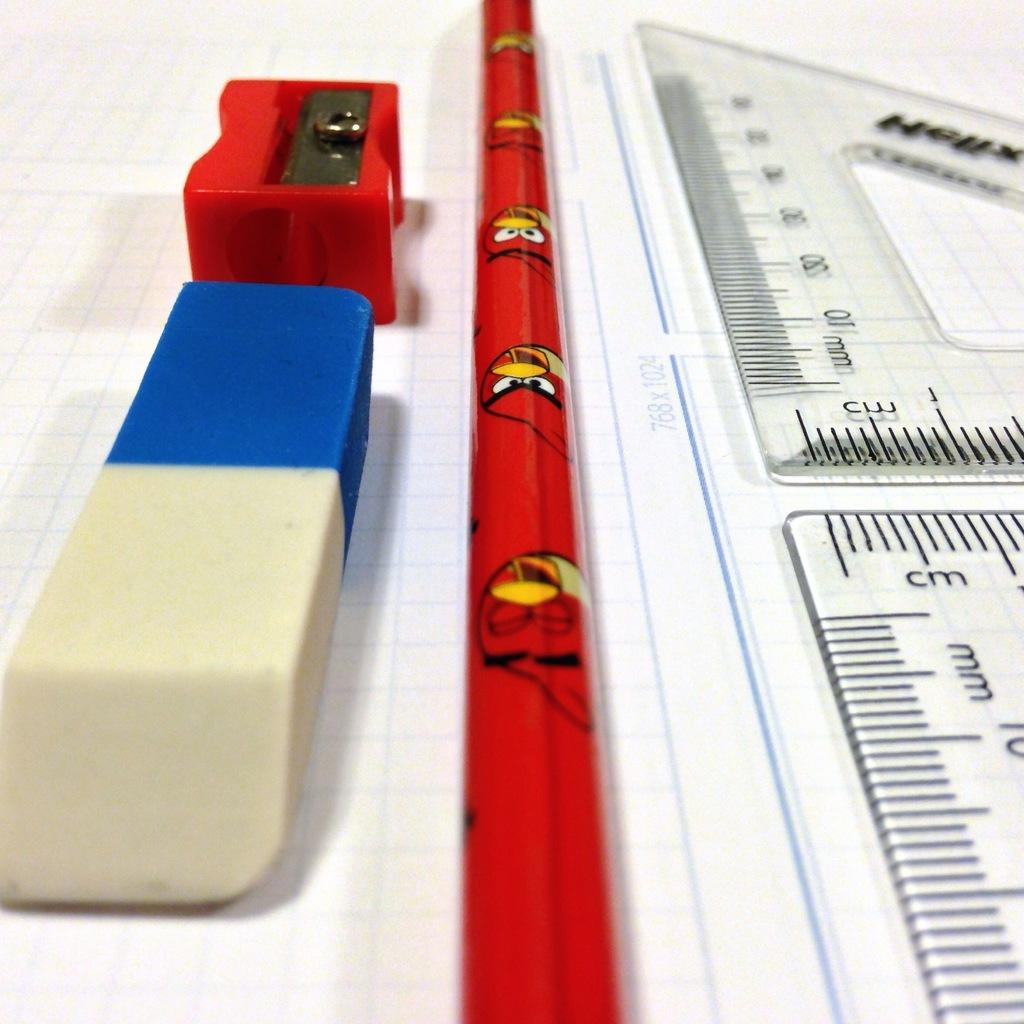What type of ruler is this/?
Keep it short and to the point. Cm. 